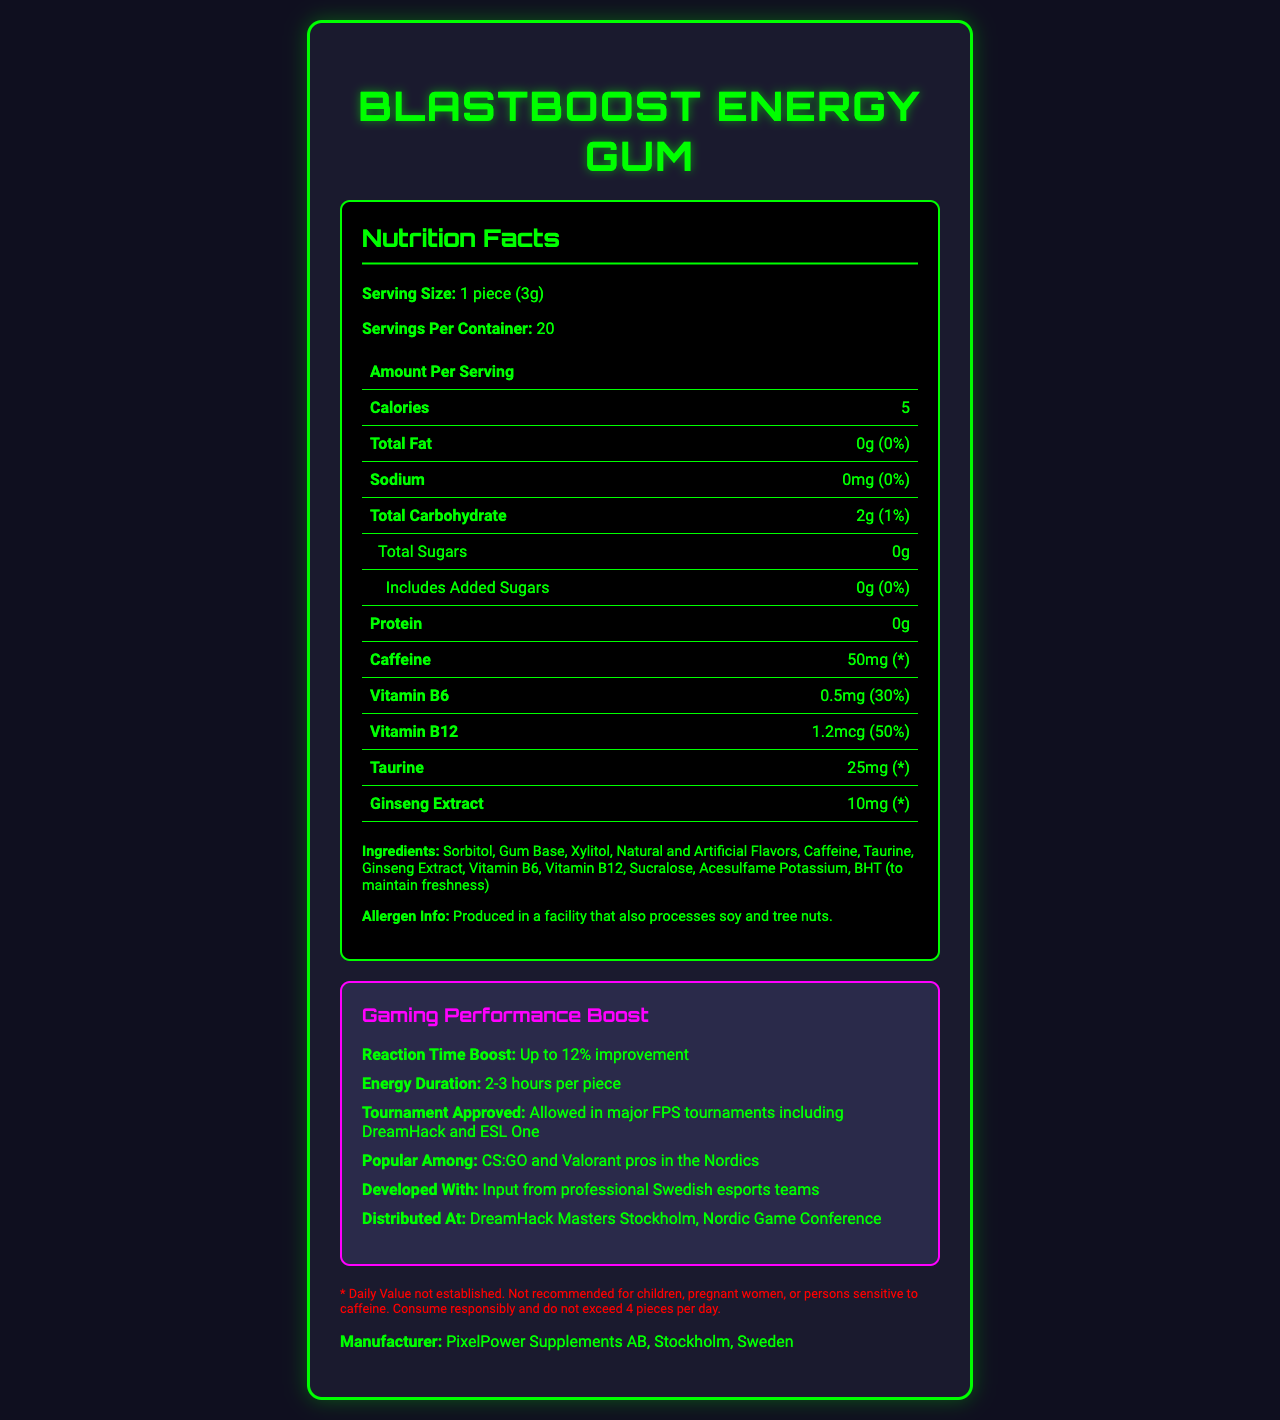what is the serving size of BlastBoost Energy Gum? The serving size is clearly stated as "1 piece (3g)" in the Nutrition Facts section.
Answer: 1 piece (3g) how many servings are in a container? The document specifies that there are 20 servings per container.
Answer: 20 how many calories are in one serving? It mentions directly in the Nutrition Facts that each serving has 5 calories.
Answer: 5 how much caffeine does each piece of gum contain? The Nutrition Facts section lists caffeine as 50mg per serving.
Answer: 50mg what is the daily value percentage of Vitamin B6 in one piece of gum? The document mentions that one piece of gum provides 30% of the daily value for Vitamin B6.
Answer: 30% which vitamins are included in the gum? A. Vitamin C and Vitamin D B. Vitamin B6 and Vitamin B12 C. Vitamin A and Vitamin E The document lists Vitamin B6 and Vitamin B12 among the ingredients and nutrition information.
Answer: B what is the total amount of sugar in each serving? The Nutrition Facts state that total sugars per serving are 0g.
Answer: 0g Is the gum approved for use in major FPS tournaments? The document specifically notes that the gum is allowed in major FPS tournaments including DreamHack and ESL One.
Answer: Yes summarize the main benefits of BlastBoost Energy Gum for gamers The gum provides a quick energy boost with a specific focus on improving reaction times by up to 12%. The energy lasts for 2-3 hours, and it is also tournament-approved, making it ideal for competitive gaming scenarios.
Answer: Quick energy boost with improved reaction times, up to 2-3 hours of energy, and approval for use in major FPS tournaments who manufactures BlastBoost Energy Gum? The manufacturer information is clearly listed as "PixelPower Supplements AB, Stockholm, Sweden."
Answer: PixelPower Supplements AB, Stockholm, Sweden what are the main ingredients in the gum aside from caffeine? These ingredients are all listed in the Ingredients section of the document.
Answer: Sorbitol, Gum Base, Xylitol, Natural and Artificial Flavors, Taurine, Ginseng Extract, Vitamin B6, Vitamin B12, Sucralose, Acesulfame Potassium, BHT is BlastBoost Energy Gum considered safe for children? The document contains a disclaimer stating it is not recommended for children, pregnant women, or persons sensitive to caffeine.
Answer: No can I consume 10 pieces of BlastBoost Energy Gum in one day? A. Yes B. No C. Maybe The disclaimer advises not to exceed 4 pieces per day, indicating it would be unsafe to consume 10 pieces.
Answer: B what is the total fat content in a serving of BlastBoost Energy Gum? The Nutrition Facts indicate that the total fat content per serving is 0g.
Answer: 0g how long does the energy boost from one piece of gum last? The gaming-specific information states that the energy duration per piece is 2-3 hours.
Answer: 2-3 hours what allergen is processed in the facility where the gum is made? The allergen information states that the gum is produced in a facility that also processes soy and tree nuts.
Answer: Soy and tree nuts how much taurine is in each piece of gum? The Nutrition Facts section lists 25mg of taurine per serving.
Answer: 25mg name one event where BlastBoost Energy Gum has been distributed The document states the gum has been distributed at DreamHack Masters Stockholm and the Nordic Game Conference.
Answer: DreamHack Masters Stockholm or Nordic Game Conference what is the energy source for the gum? The combination of these ingredients is intended to provide a quick energy boost.
Answer: Caffeine, Taurine, Ginseng Extract, Vitamins B6 and B12 who are the main users of BlastBoost Energy Gum in Sweden? A. RPG Gamers B. FPS Gamers C. Mobile Gamers The document highlights that it is popular among CS:GO and Valorant pros in the Nordics, indicating its primary users are FPS gamers.
Answer: B how does BlastBoost Energy Gum improve gaming performance? The gaming-specific info states that the gum can improve reaction time by up to 12%.
Answer: Up to 12% improvement in reaction time how much protein is in each piece of gum? The Nutrition Facts disclose that each piece of gum contains 0g of protein.
Answer: 0g how many pieces of BlastBoost Energy Gum can be consumed safely in one day? The disclaimer clearly recommends not exceeding 4 pieces per day for safe consumption.
Answer: 4 pieces what is the nightly duration of DreamHack Master Stockholm Gaming event? The document does not provide any information about the specific duration of the DreamHack Masters Stockholm event.
Answer: Cannot be determined 